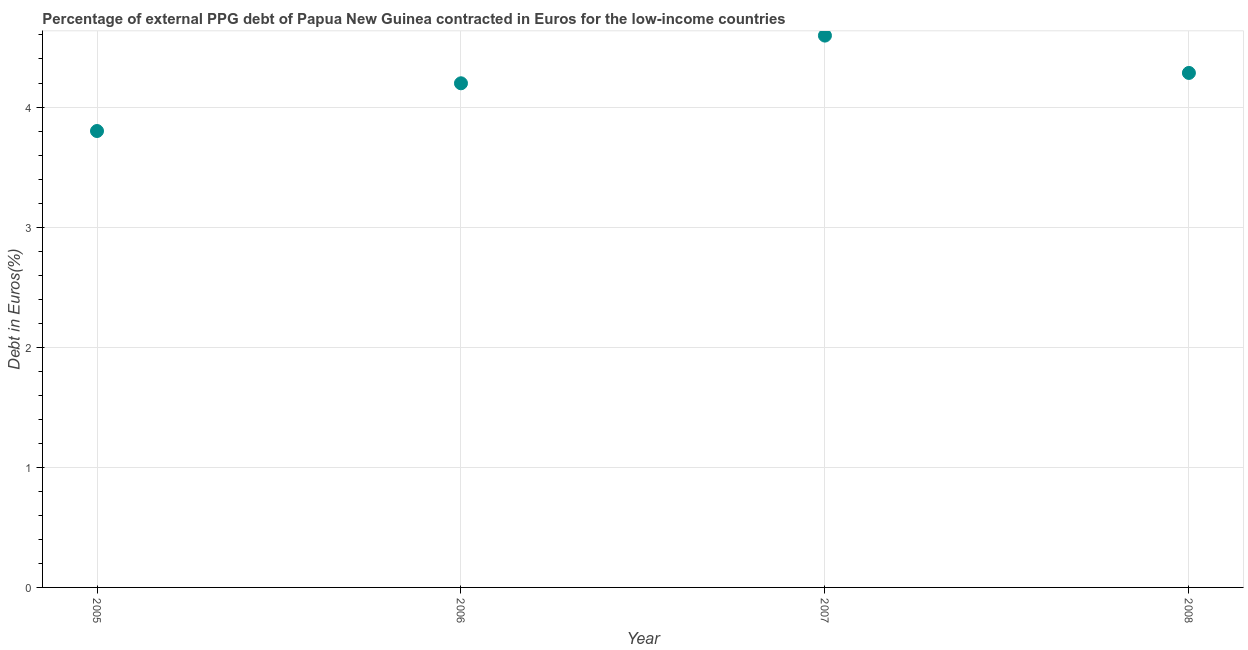What is the currency composition of ppg debt in 2006?
Provide a succinct answer. 4.2. Across all years, what is the maximum currency composition of ppg debt?
Your answer should be very brief. 4.59. Across all years, what is the minimum currency composition of ppg debt?
Ensure brevity in your answer.  3.8. In which year was the currency composition of ppg debt maximum?
Offer a terse response. 2007. What is the sum of the currency composition of ppg debt?
Offer a very short reply. 16.88. What is the difference between the currency composition of ppg debt in 2005 and 2008?
Your response must be concise. -0.48. What is the average currency composition of ppg debt per year?
Give a very brief answer. 4.22. What is the median currency composition of ppg debt?
Give a very brief answer. 4.24. Do a majority of the years between 2007 and 2005 (inclusive) have currency composition of ppg debt greater than 4 %?
Provide a succinct answer. No. What is the ratio of the currency composition of ppg debt in 2005 to that in 2006?
Ensure brevity in your answer.  0.91. What is the difference between the highest and the second highest currency composition of ppg debt?
Keep it short and to the point. 0.31. What is the difference between the highest and the lowest currency composition of ppg debt?
Make the answer very short. 0.79. In how many years, is the currency composition of ppg debt greater than the average currency composition of ppg debt taken over all years?
Provide a succinct answer. 2. Does the currency composition of ppg debt monotonically increase over the years?
Ensure brevity in your answer.  No. How many dotlines are there?
Provide a short and direct response. 1. Are the values on the major ticks of Y-axis written in scientific E-notation?
Your answer should be compact. No. Does the graph contain any zero values?
Your answer should be very brief. No. What is the title of the graph?
Provide a succinct answer. Percentage of external PPG debt of Papua New Guinea contracted in Euros for the low-income countries. What is the label or title of the Y-axis?
Your answer should be very brief. Debt in Euros(%). What is the Debt in Euros(%) in 2005?
Make the answer very short. 3.8. What is the Debt in Euros(%) in 2006?
Your response must be concise. 4.2. What is the Debt in Euros(%) in 2007?
Give a very brief answer. 4.59. What is the Debt in Euros(%) in 2008?
Offer a very short reply. 4.28. What is the difference between the Debt in Euros(%) in 2005 and 2006?
Your answer should be very brief. -0.4. What is the difference between the Debt in Euros(%) in 2005 and 2007?
Your answer should be very brief. -0.79. What is the difference between the Debt in Euros(%) in 2005 and 2008?
Your answer should be very brief. -0.48. What is the difference between the Debt in Euros(%) in 2006 and 2007?
Your answer should be very brief. -0.4. What is the difference between the Debt in Euros(%) in 2006 and 2008?
Your answer should be compact. -0.09. What is the difference between the Debt in Euros(%) in 2007 and 2008?
Your response must be concise. 0.31. What is the ratio of the Debt in Euros(%) in 2005 to that in 2006?
Make the answer very short. 0.91. What is the ratio of the Debt in Euros(%) in 2005 to that in 2007?
Give a very brief answer. 0.83. What is the ratio of the Debt in Euros(%) in 2005 to that in 2008?
Give a very brief answer. 0.89. What is the ratio of the Debt in Euros(%) in 2006 to that in 2007?
Provide a succinct answer. 0.91. What is the ratio of the Debt in Euros(%) in 2006 to that in 2008?
Give a very brief answer. 0.98. What is the ratio of the Debt in Euros(%) in 2007 to that in 2008?
Provide a succinct answer. 1.07. 